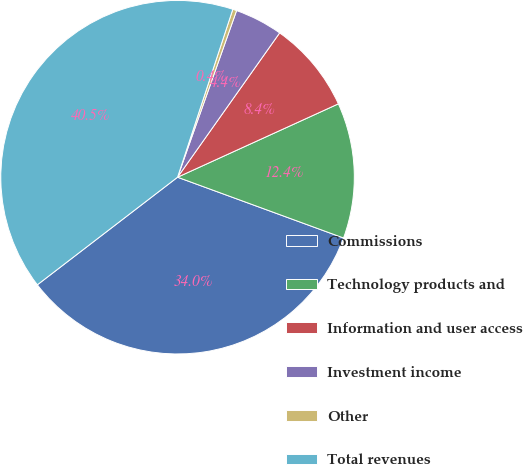Convert chart. <chart><loc_0><loc_0><loc_500><loc_500><pie_chart><fcel>Commissions<fcel>Technology products and<fcel>Information and user access<fcel>Investment income<fcel>Other<fcel>Total revenues<nl><fcel>34.0%<fcel>12.4%<fcel>8.39%<fcel>4.38%<fcel>0.36%<fcel>40.48%<nl></chart> 